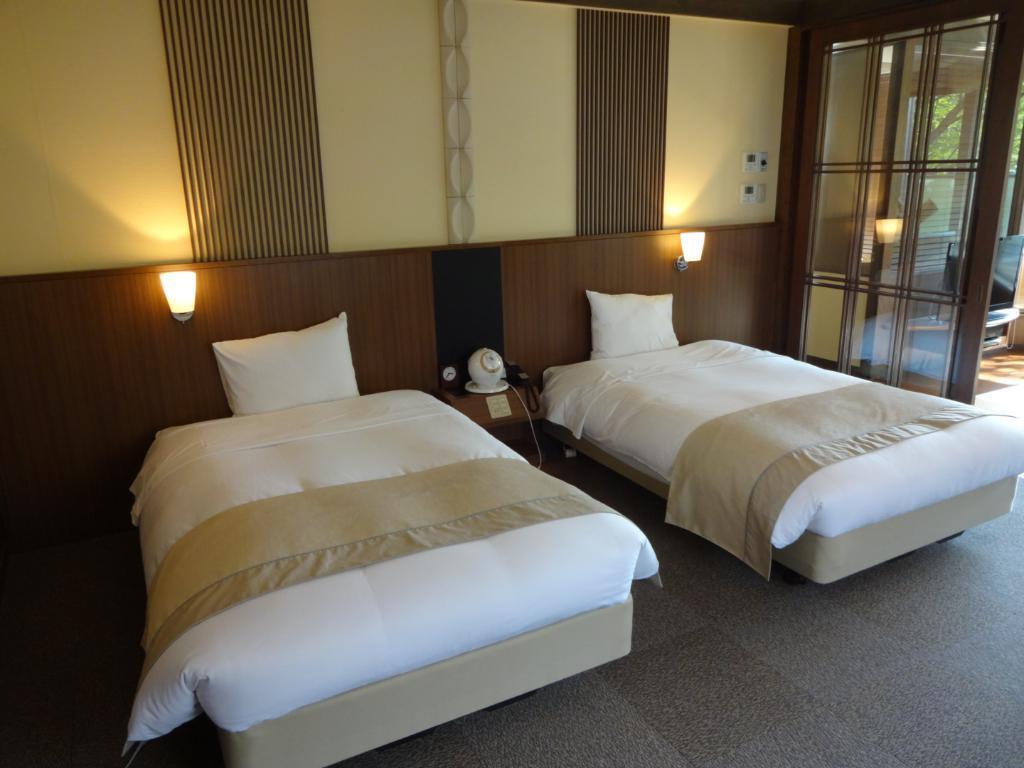Describe this image in one or two sentences. In this image two beds are on the floor. In between the beds there is a table having a telephone and few objects on it. Few lights are attached to the wall. Right side there is a door. Behind there are few objects on the floor. 